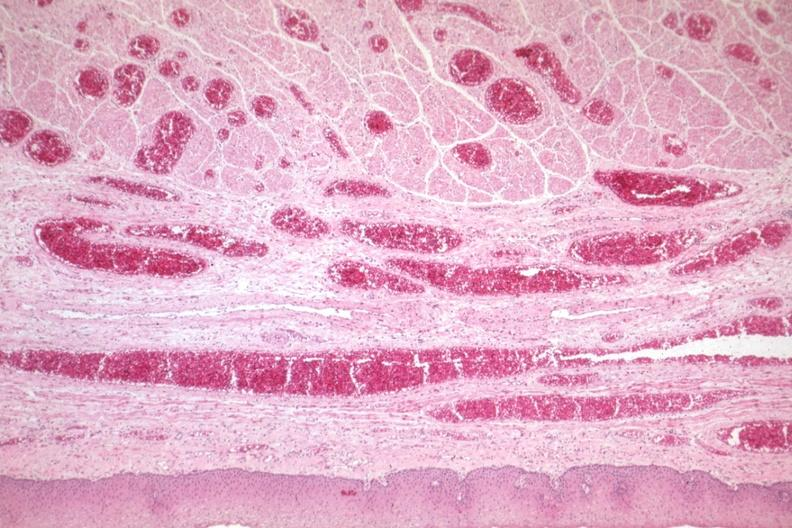does this image show good example of veins filled with blood?
Answer the question using a single word or phrase. Yes 